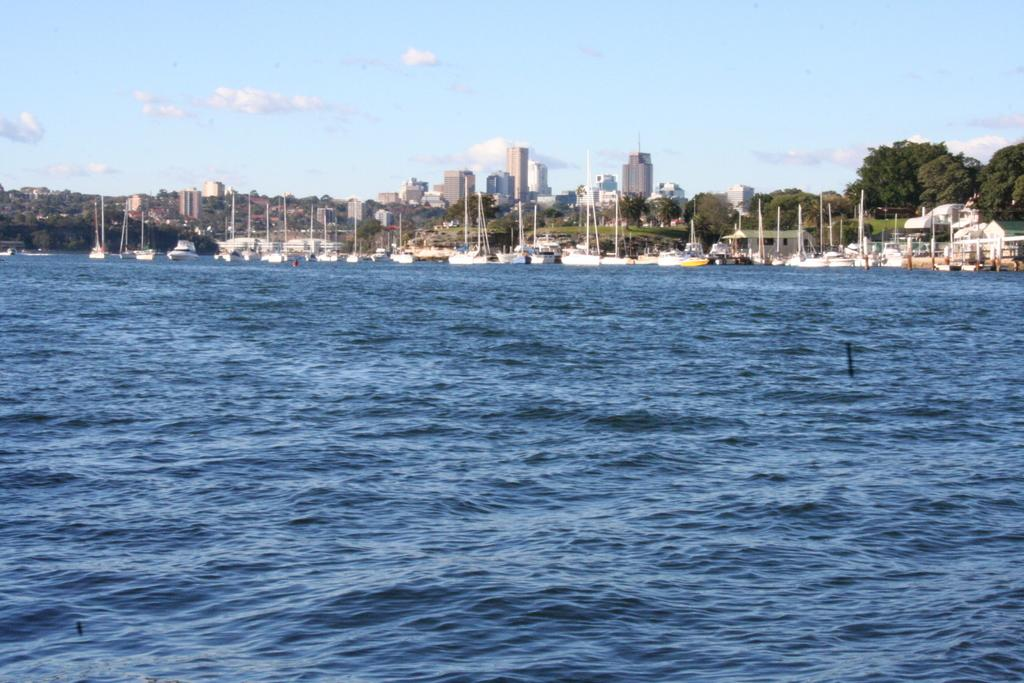What is at the bottom of the image? There is water at the bottom of the image. What type of vegetation can be seen in the image? There are trees in the image. What type of structures are present in the image? There are buildings in the image. What is visible in the sky in the image? The sky is visible in the image, and there are clouds present. What does the mouth of the tree look like in the image? There are no mouths present on the trees in the image, as trees do not have mouths. What is the plot of the story being told in the image? The image does not depict a story or plot; it is a visual representation of various elements such as water, trees, buildings, and the sky. 